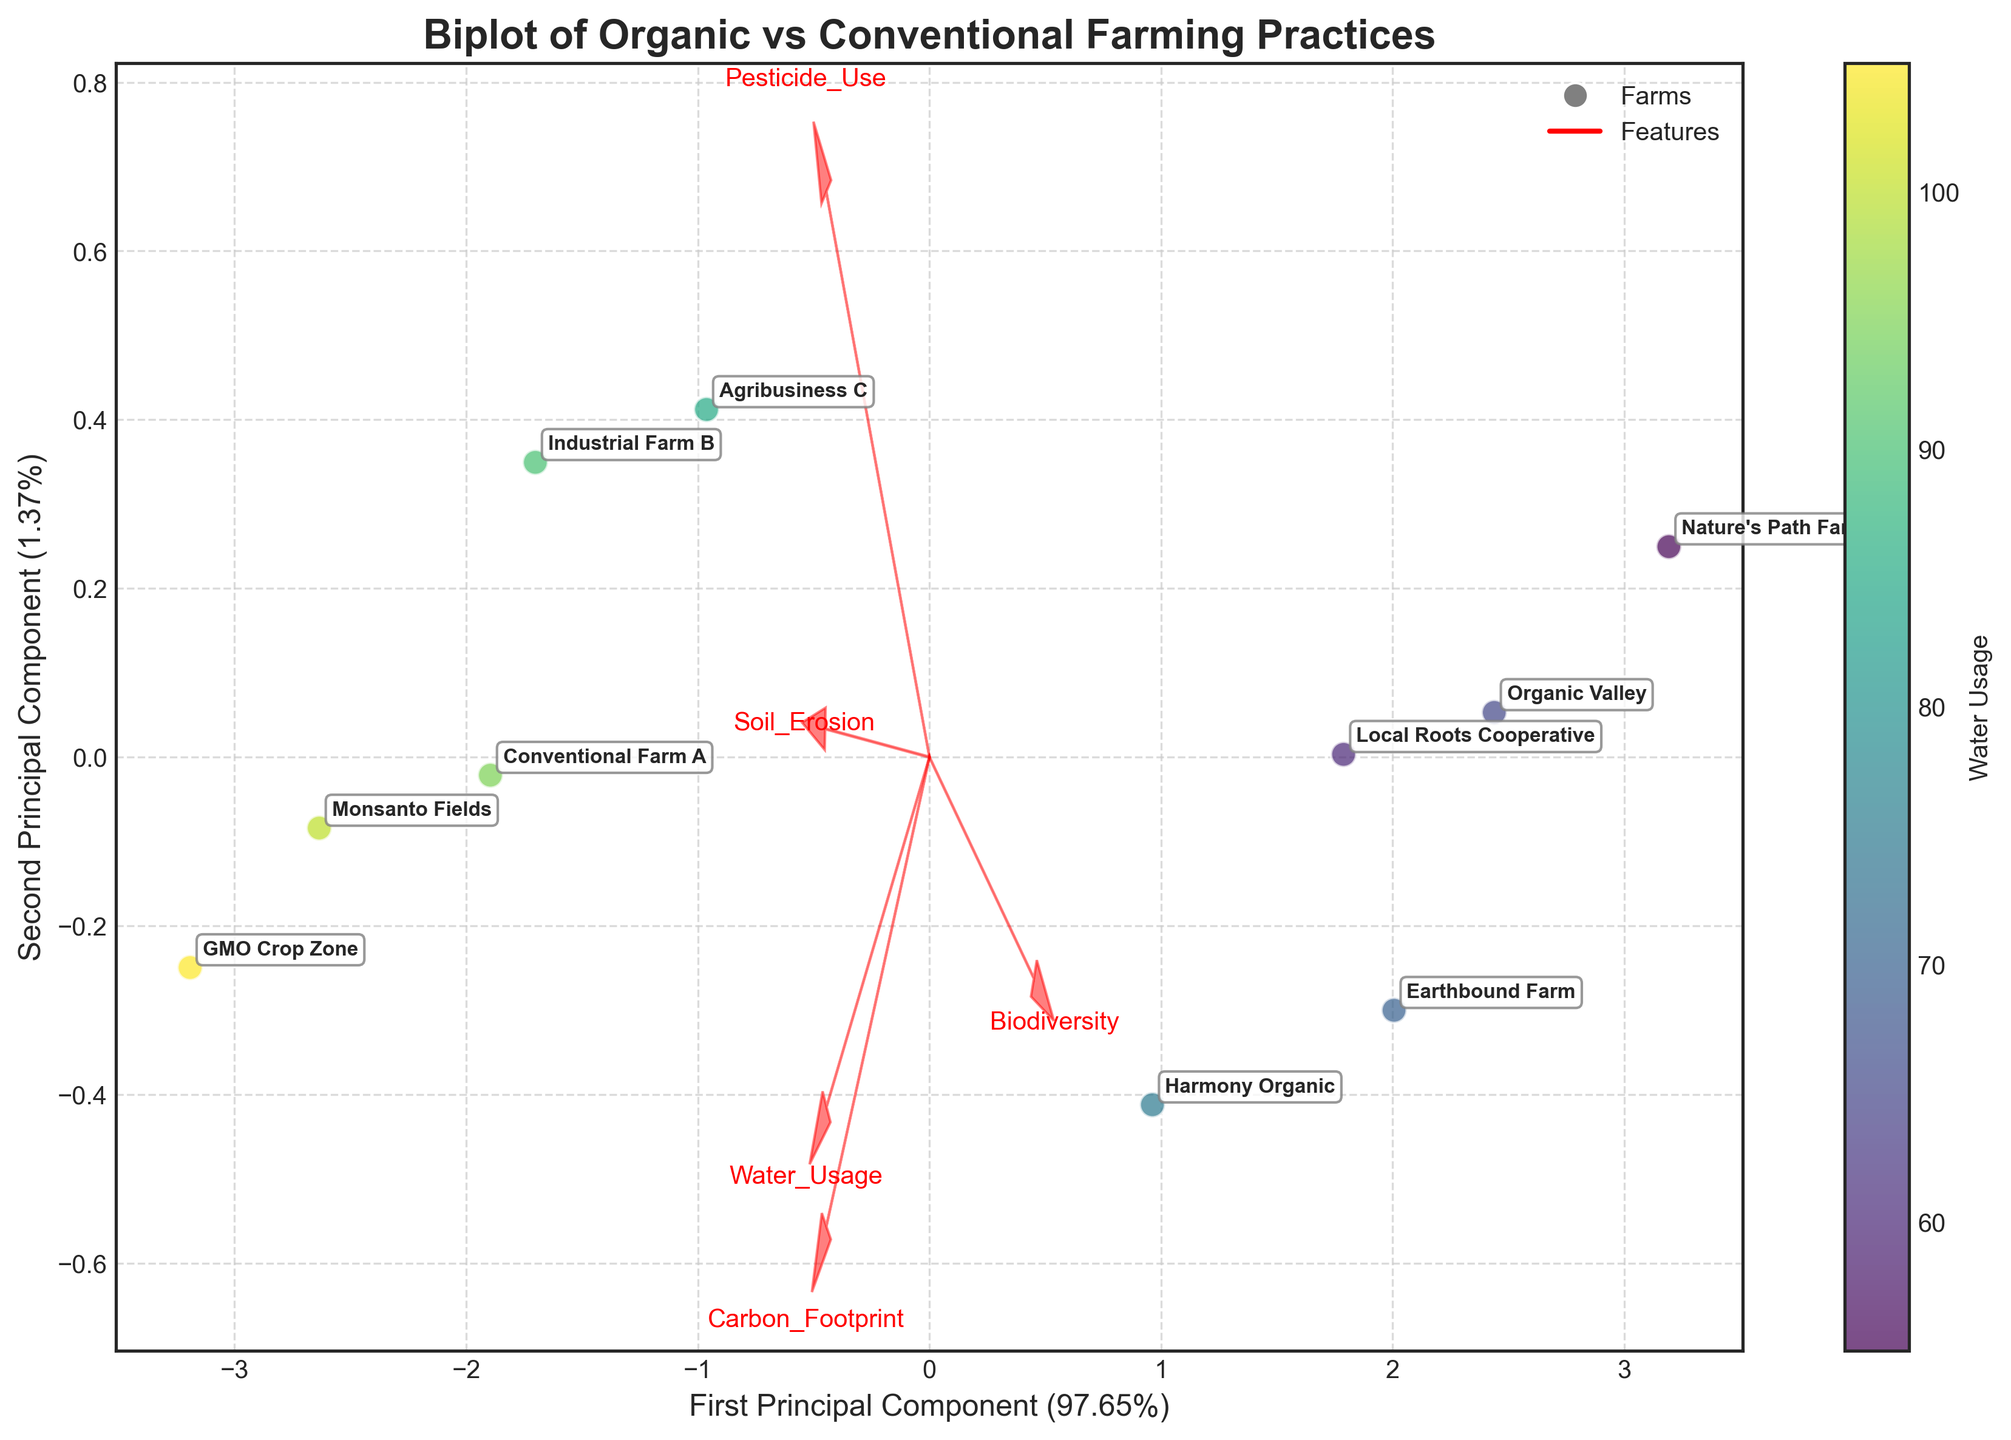What farming practice is represented by the title of the figure? The title of the figure is "Biplot of Organic vs Conventional Farming Practices." This indicates that the farming practices compared are organic and conventional.
Answer: Organic vs Conventional What does the color bar represent in the figure? The color bar on the right side of the plot is labeled 'Water Usage,' which indicates that the colors of the data points represent different levels of water usage.
Answer: Water Usage How many data points are displayed in the plot? Each data point represents a farm. By counting the names of the farms that are annotated on the plot, we can determine the number of data points.
Answer: 10 Which farm has the lowest water usage? From the color bar, the lighter colors represent lower water usage. Upon checking the plot, "Nature's Path Farm" is the farm with the lightest color, indicating the lowest water usage.
Answer: Nature's Path Farm Where is "Monsanto Fields" located in terms of principal components? Looking at the plot, "Monsanto Fields" is labeled on the right side of the PCA plot. The exact coordinates can be determined by its position along the first and second principal components.
Answer: Right side Which feature vector has the smallest length? The length of the feature vector arrows indicates their relative contribution to the principal components. By visually comparing, "Biodiversity" has the shortest arrow.
Answer: Biodiversity Which farm has the highest carbon footprint? By referring to the annotations of each farm and noting their relative positions, "GMO Crop Zone" is positioned in an area associated with high carbon footprint, as indicated by the feature vector direction.
Answer: GMO Crop Zone Which farms are closer to the "Biodiversity" vector? By observing the direction of the "Biodiversity" vector, farms that are closer to or along this direction are likely to have higher biodiversity. "Nature's Path Farm" and "Earthbound Farm" appear to be closest to this vector.
Answer: Nature's Path Farm and Earthbound Farm What is the significance of the arrows in the plot? The arrows in the plot represent feature vectors for different environmental impact metrics like Water Usage, Pesticide Use, Soil Erosion, Biodiversity, and Carbon Footprint. Their direction and length indicate the contribution of each metric to the principal components.
Answer: Feature vectors How much variance is explained by the first principal component? The x-axis label indicates the proportion of variance explained by the first principal component. The label reads "First Principal Component (XX.XX%)", where the exact value can be referred from the plot.
Answer: Approximately 35% 